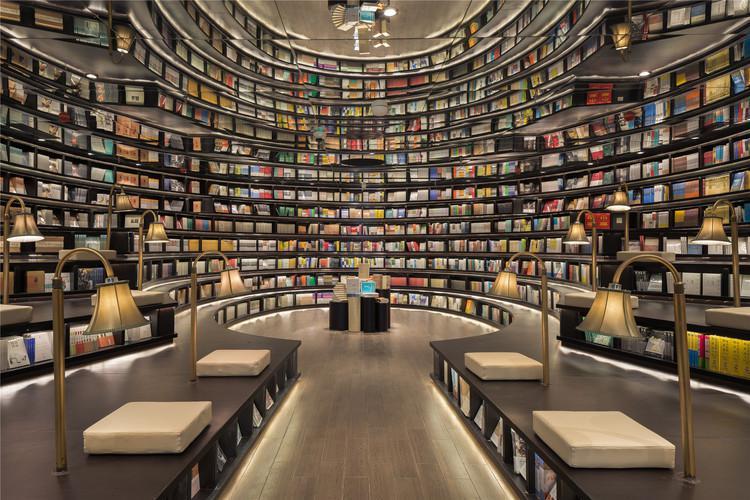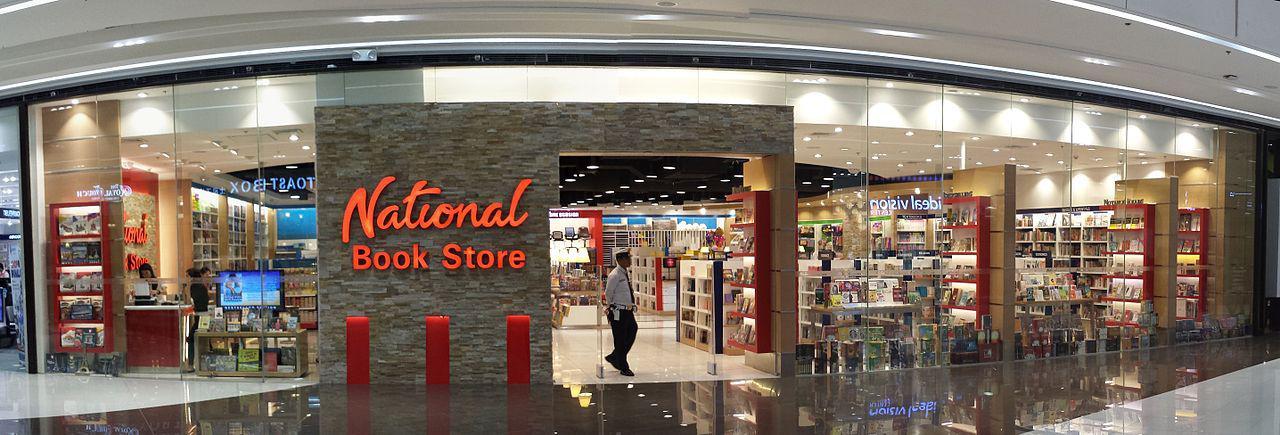The first image is the image on the left, the second image is the image on the right. Assess this claim about the two images: "There is a thin and tall standalone bookshelf in the centre of the left image.". Correct or not? Answer yes or no. No. 